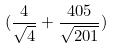<formula> <loc_0><loc_0><loc_500><loc_500>( \frac { 4 } { \sqrt { 4 } } + \frac { 4 0 5 } { \sqrt { 2 0 1 } } )</formula> 